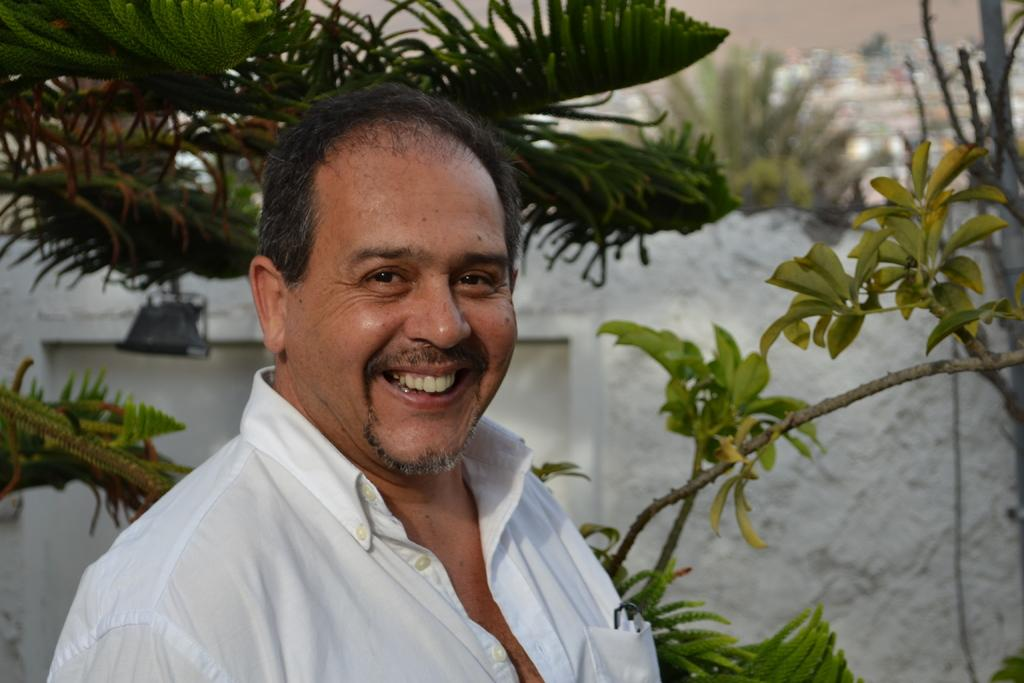What is the main subject of the image? There is a person in the image. What is the person wearing? The person is wearing a white shirt. What is the person's facial expression? The person is smiling. What can be seen in the background of the image? There are trees, a white wall, and other objects in the background of the image. What type of pan is being used by the monkey in the image? There is no monkey or pan present in the image. Who is the representative of the group in the image? The image does not depict a group or a representative; it only shows a person. 